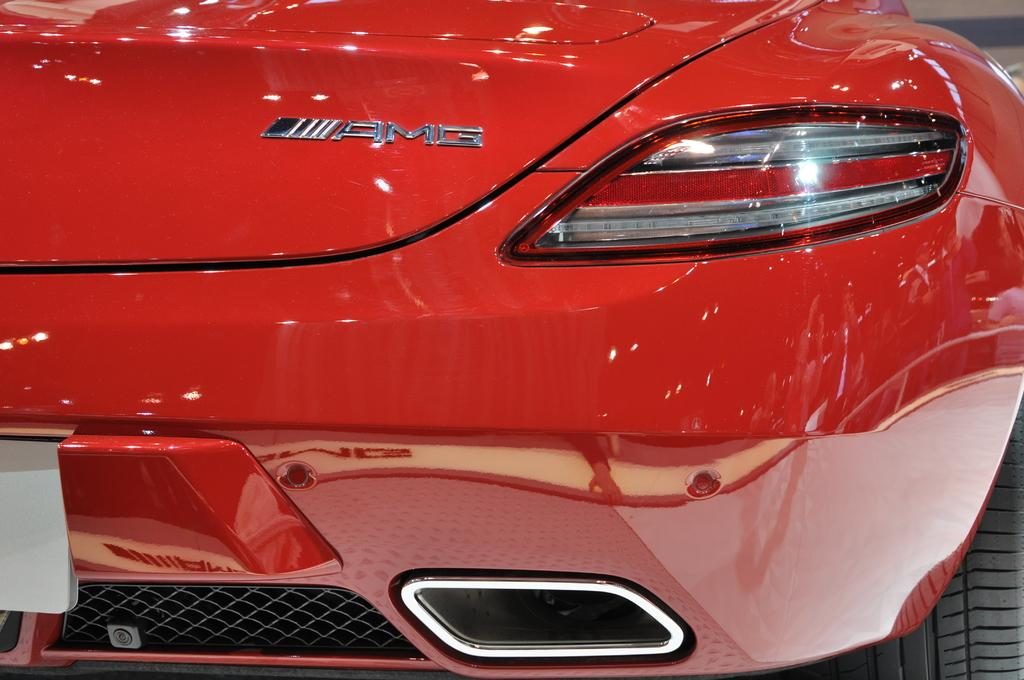What is the main subject of the image? The main subject of the image is a car. Can you describe any specific features of the car? Yes, there is a logo on the top of the car and a headlight on the right side of the car in the image. What type of ball can be seen bouncing in the car's hall in the image? There is no ball or hall present in the image; it is a zoomed-in view of a car with a logo and a headlight. 